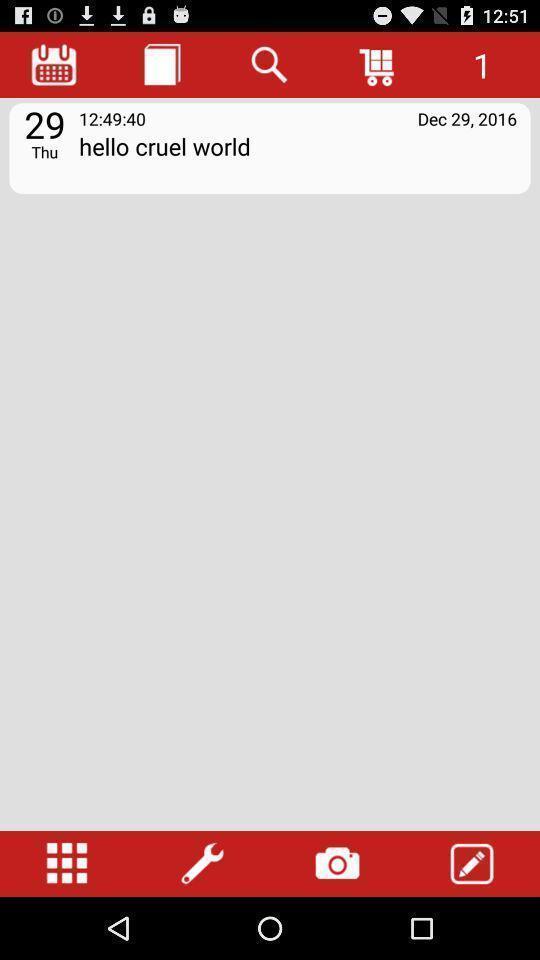Explain the elements present in this screenshot. Screen showing note with options. 